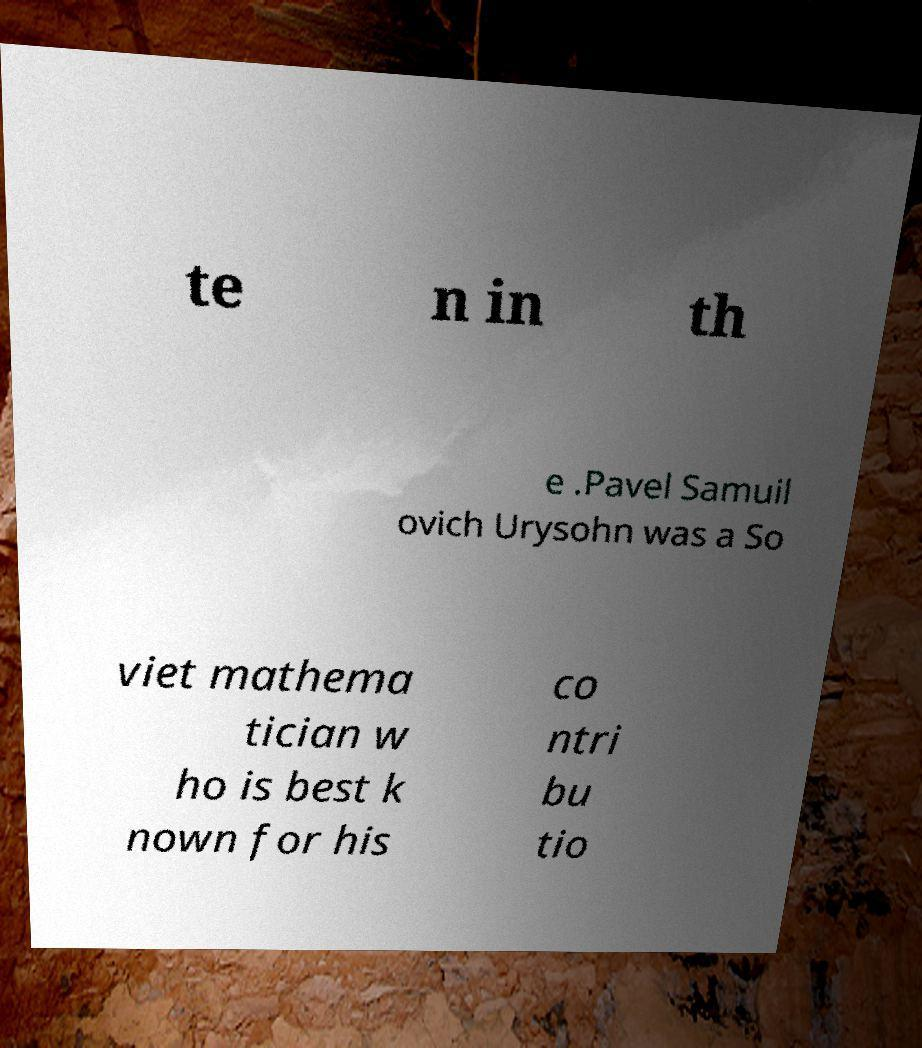Please read and relay the text visible in this image. What does it say? te n in th e .Pavel Samuil ovich Urysohn was a So viet mathema tician w ho is best k nown for his co ntri bu tio 